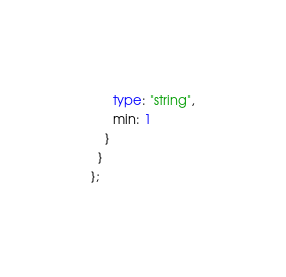Convert code to text. <code><loc_0><loc_0><loc_500><loc_500><_TypeScript_>      type: "string",
      min: 1
    }
  }
};
</code> 